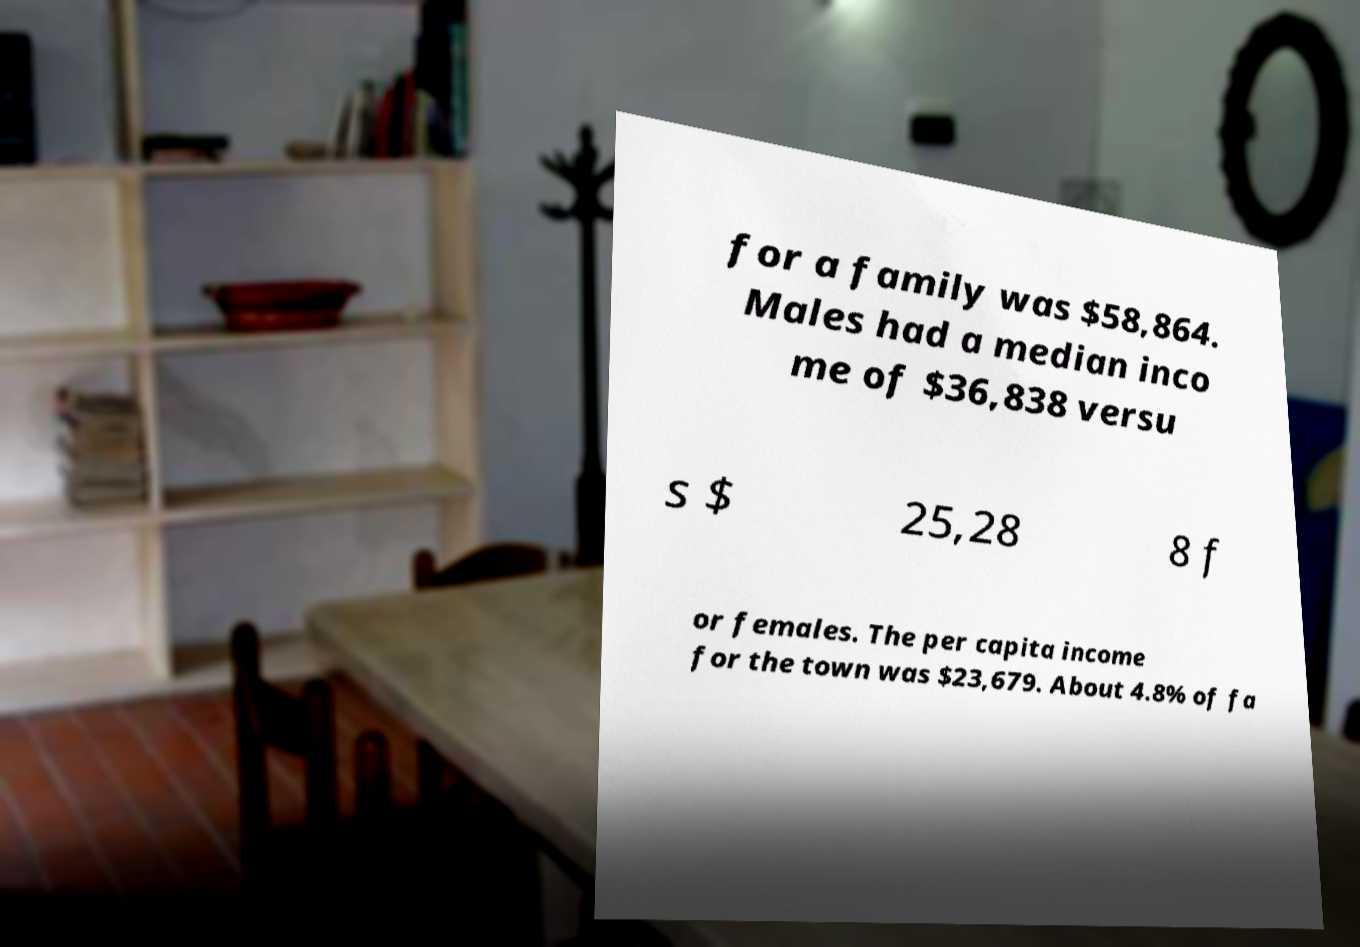Please identify and transcribe the text found in this image. for a family was $58,864. Males had a median inco me of $36,838 versu s $ 25,28 8 f or females. The per capita income for the town was $23,679. About 4.8% of fa 